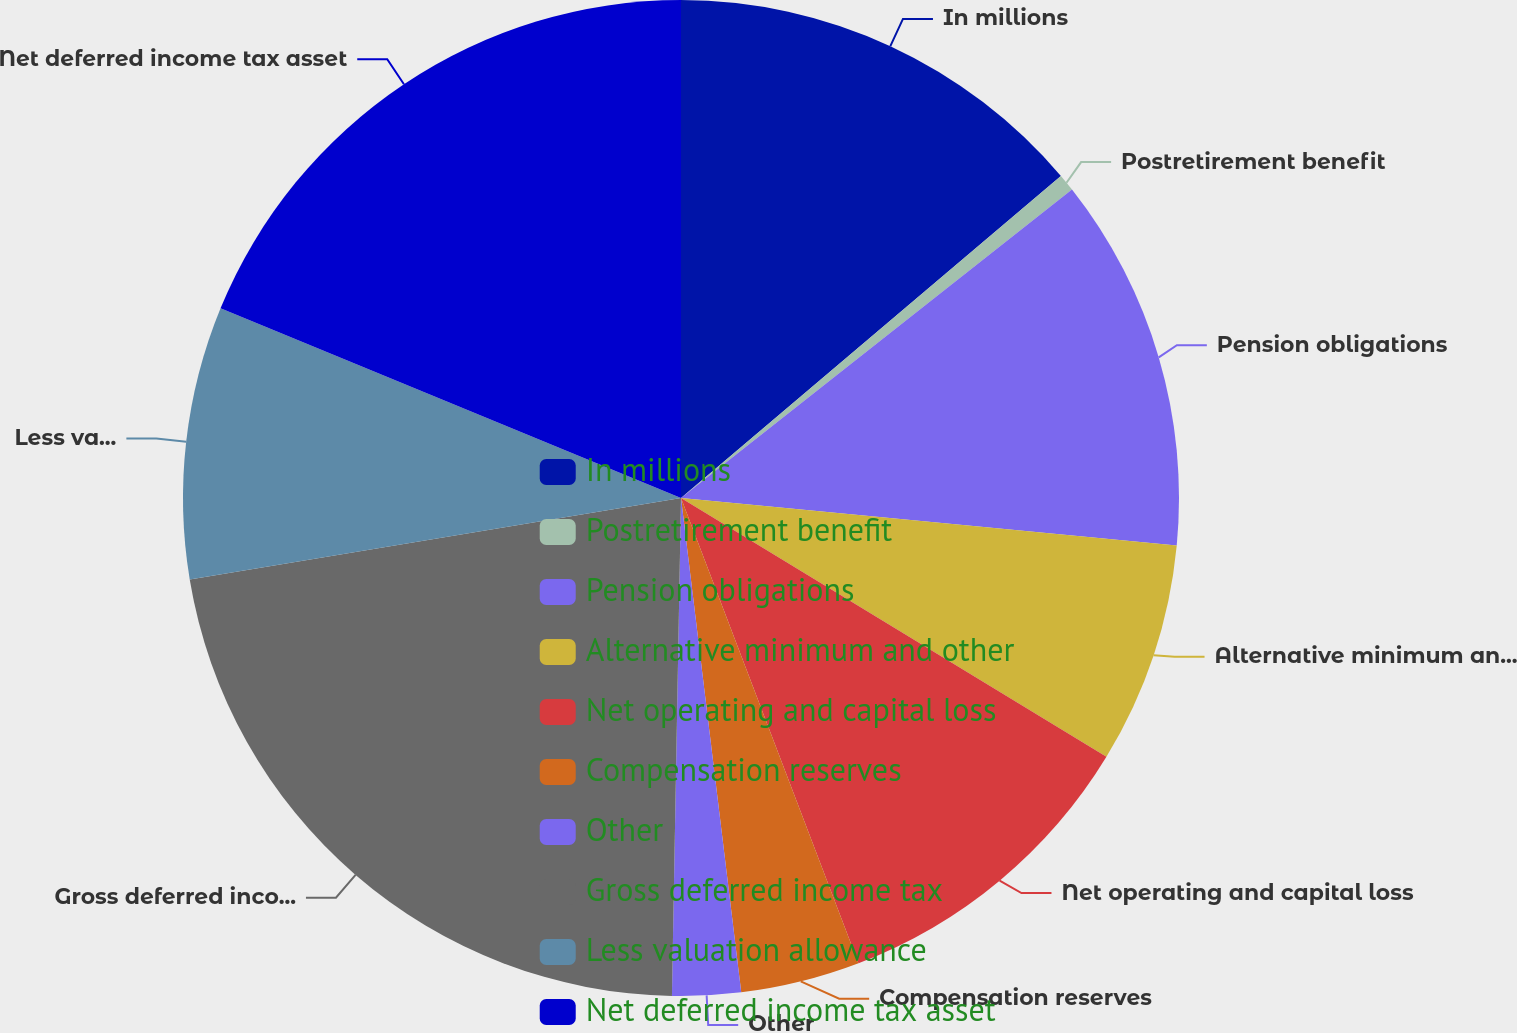<chart> <loc_0><loc_0><loc_500><loc_500><pie_chart><fcel>In millions<fcel>Postretirement benefit<fcel>Pension obligations<fcel>Alternative minimum and other<fcel>Net operating and capital loss<fcel>Compensation reserves<fcel>Other<fcel>Gross deferred income tax<fcel>Less valuation allowance<fcel>Net deferred income tax asset<nl><fcel>13.81%<fcel>0.56%<fcel>12.15%<fcel>7.18%<fcel>10.5%<fcel>3.87%<fcel>2.22%<fcel>22.09%<fcel>8.84%<fcel>18.78%<nl></chart> 